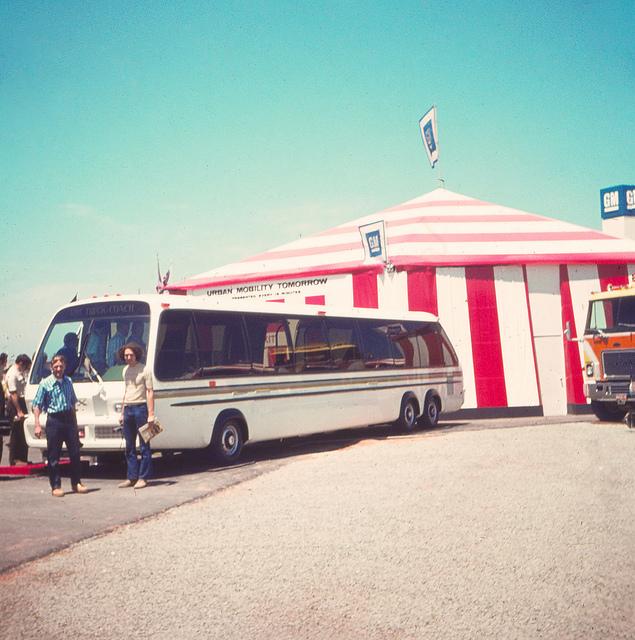What color is the object on the truck to the left of the people?
Be succinct. Red. How many people are visible in this picture?
Give a very brief answer. 4. Is this a new bus?
Be succinct. No. Is the RV parked on a dirt road?
Write a very short answer. No. Which arm is the driver?
Concise answer only. Right. What color is the girl's jacket?
Write a very short answer. White. What kind of vehicle is pictured?
Concise answer only. Bus. Is the red and white building permanent?
Write a very short answer. No. How many stones are next to the bus?
Give a very brief answer. 0. How many levels does the bus have?
Answer briefly. 1. Are the people having fun?
Keep it brief. Yes. Are these people getting on a bus?
Keep it brief. Yes. 